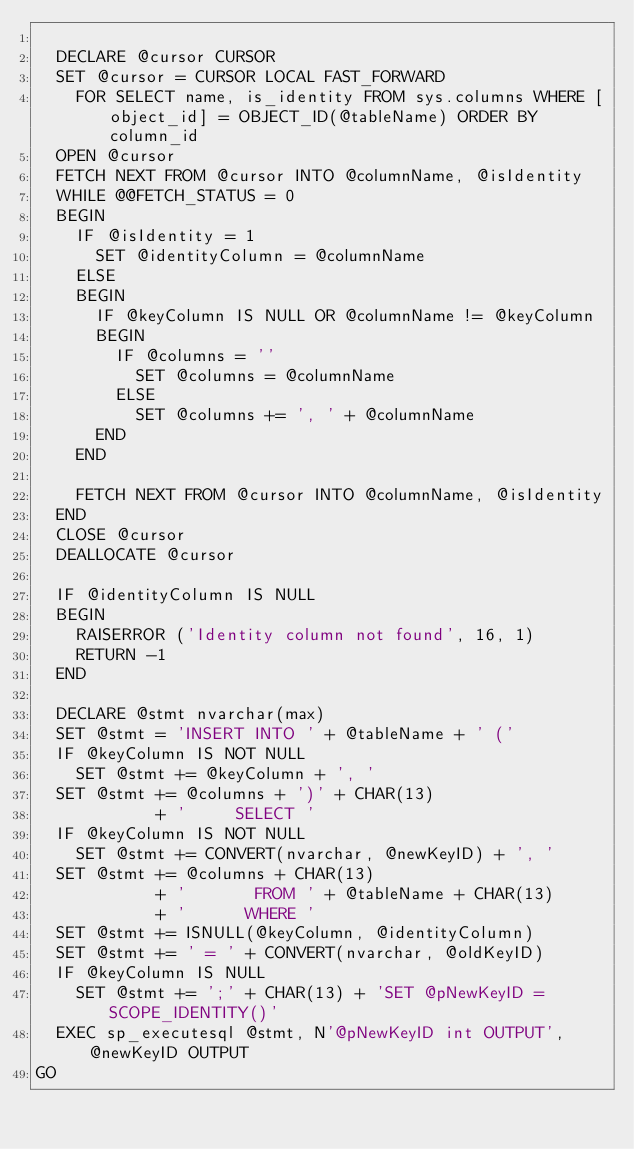<code> <loc_0><loc_0><loc_500><loc_500><_SQL_>
  DECLARE @cursor CURSOR
  SET @cursor = CURSOR LOCAL FAST_FORWARD
    FOR SELECT name, is_identity FROM sys.columns WHERE [object_id] = OBJECT_ID(@tableName) ORDER BY column_id
  OPEN @cursor
  FETCH NEXT FROM @cursor INTO @columnName, @isIdentity
  WHILE @@FETCH_STATUS = 0
  BEGIN
    IF @isIdentity = 1
      SET @identityColumn = @columnName
    ELSE
    BEGIN
      IF @keyColumn IS NULL OR @columnName != @keyColumn
      BEGIN
        IF @columns = ''
          SET @columns = @columnName
        ELSE
          SET @columns += ', ' + @columnName
      END
    END

    FETCH NEXT FROM @cursor INTO @columnName, @isIdentity
  END
  CLOSE @cursor
  DEALLOCATE @cursor

  IF @identityColumn IS NULL
  BEGIN
    RAISERROR ('Identity column not found', 16, 1)
    RETURN -1
  END

  DECLARE @stmt nvarchar(max)
  SET @stmt = 'INSERT INTO ' + @tableName + ' ('
  IF @keyColumn IS NOT NULL
    SET @stmt += @keyColumn + ', '
  SET @stmt += @columns + ')' + CHAR(13)
            + '     SELECT '
  IF @keyColumn IS NOT NULL
    SET @stmt += CONVERT(nvarchar, @newKeyID) + ', '
  SET @stmt += @columns + CHAR(13)
            + '       FROM ' + @tableName + CHAR(13)
            + '      WHERE '
  SET @stmt += ISNULL(@keyColumn, @identityColumn)
  SET @stmt += ' = ' + CONVERT(nvarchar, @oldKeyID)
  IF @keyColumn IS NULL
    SET @stmt += ';' + CHAR(13) + 'SET @pNewKeyID = SCOPE_IDENTITY()'
  EXEC sp_executesql @stmt, N'@pNewKeyID int OUTPUT', @newKeyID OUTPUT
GO
</code> 